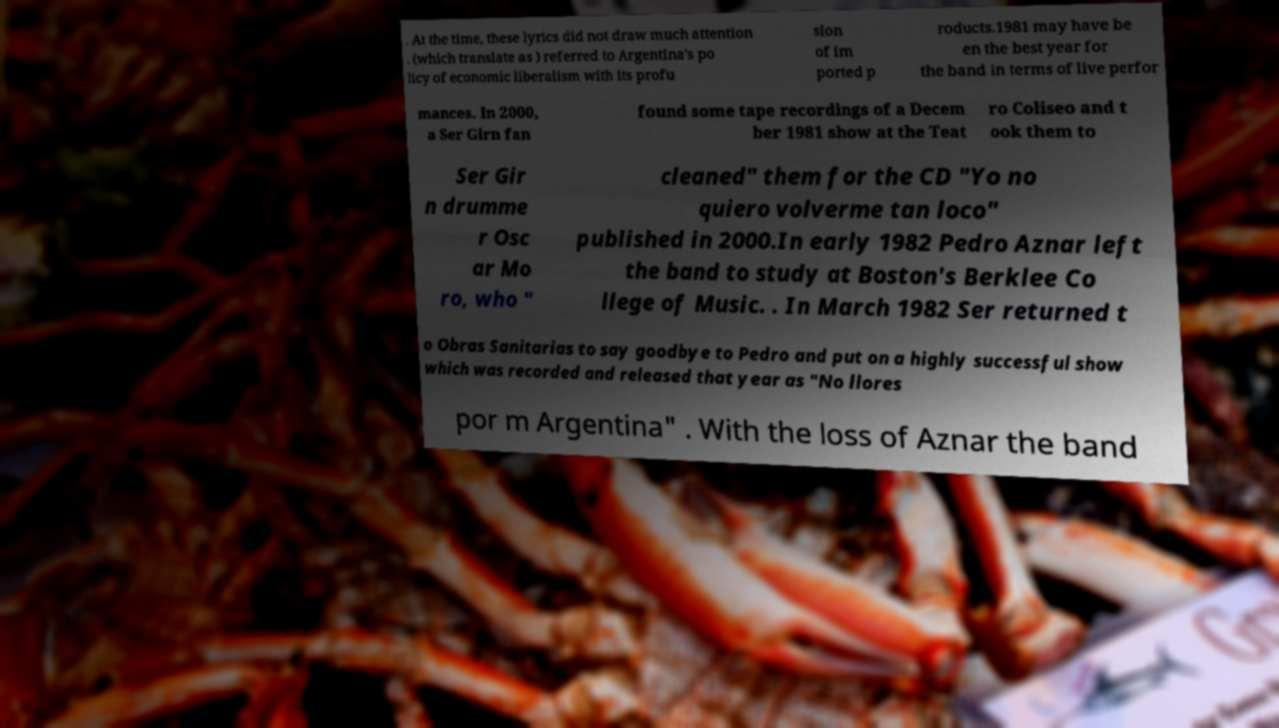What messages or text are displayed in this image? I need them in a readable, typed format. . At the time, these lyrics did not draw much attention . (which translate as ) referred to Argentina's po licy of economic liberalism with its profu sion of im ported p roducts.1981 may have be en the best year for the band in terms of live perfor mances. In 2000, a Ser Girn fan found some tape recordings of a Decem ber 1981 show at the Teat ro Coliseo and t ook them to Ser Gir n drumme r Osc ar Mo ro, who " cleaned" them for the CD "Yo no quiero volverme tan loco" published in 2000.In early 1982 Pedro Aznar left the band to study at Boston's Berklee Co llege of Music. . In March 1982 Ser returned t o Obras Sanitarias to say goodbye to Pedro and put on a highly successful show which was recorded and released that year as "No llores por m Argentina" . With the loss of Aznar the band 